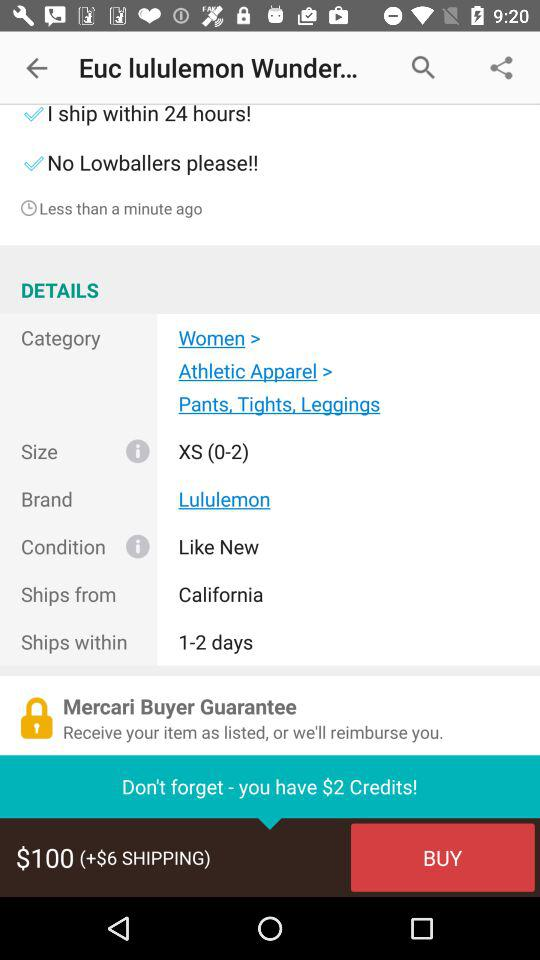How many days does the seller say it will take to ship?
Answer the question using a single word or phrase. 1-2 days 